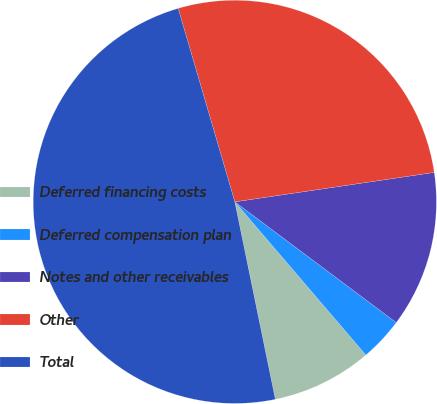Convert chart. <chart><loc_0><loc_0><loc_500><loc_500><pie_chart><fcel>Deferred financing costs<fcel>Deferred compensation plan<fcel>Notes and other receivables<fcel>Other<fcel>Total<nl><fcel>8.04%<fcel>3.52%<fcel>12.55%<fcel>27.2%<fcel>48.68%<nl></chart> 